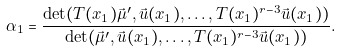<formula> <loc_0><loc_0><loc_500><loc_500>\alpha _ { 1 } = \frac { \det ( T ( x _ { 1 } ) \vec { \mu } ^ { \prime } , \vec { u } ( x _ { 1 } ) , \dots , T ( x _ { 1 } ) ^ { r - 3 } \vec { u } ( x _ { 1 } ) ) } { \det ( \vec { \mu } ^ { \prime } , \vec { u } ( x _ { 1 } ) , \dots , T ( x _ { 1 } ) ^ { r - 3 } \vec { u } ( x _ { 1 } ) ) } .</formula> 